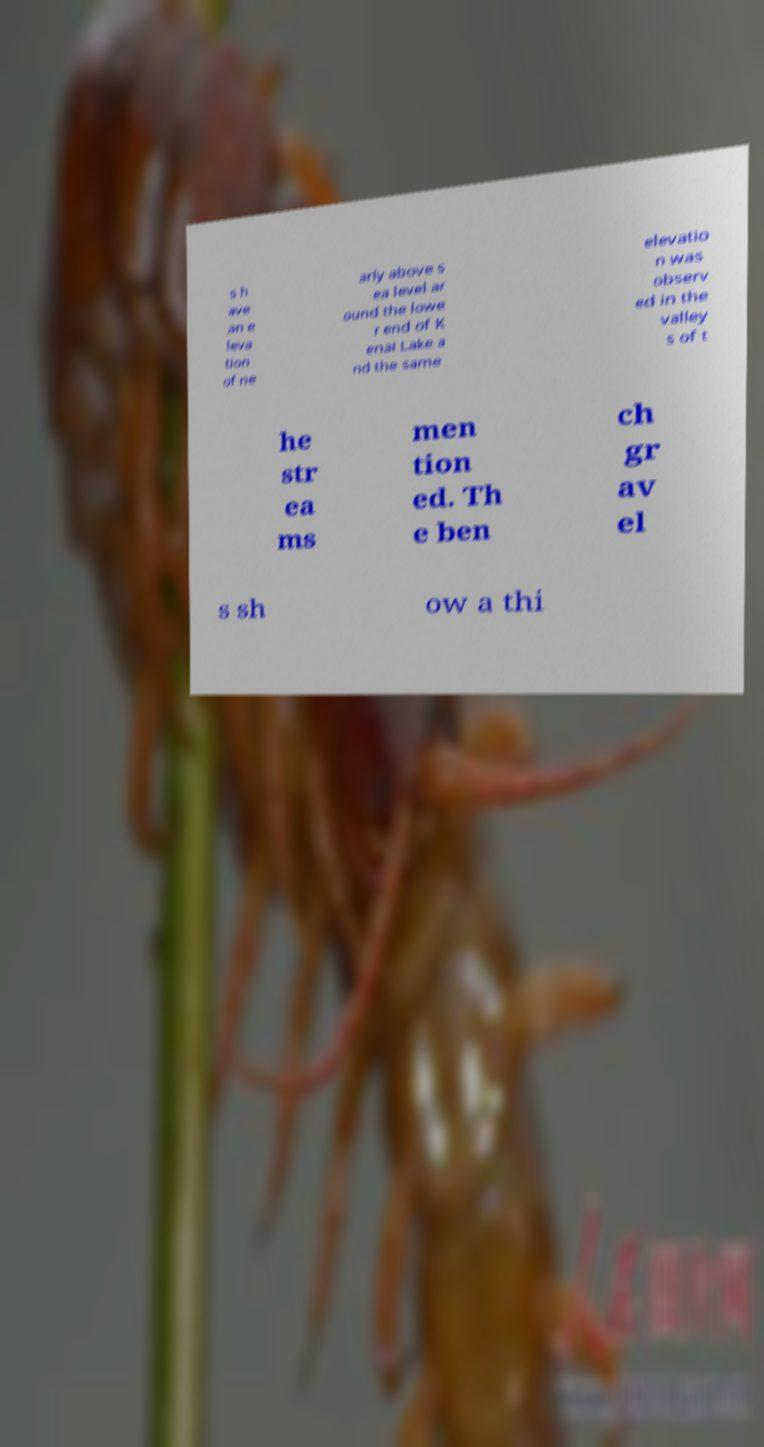Could you assist in decoding the text presented in this image and type it out clearly? s h ave an e leva tion of ne arly above s ea level ar ound the lowe r end of K enai Lake a nd the same elevatio n was observ ed in the valley s of t he str ea ms men tion ed. Th e ben ch gr av el s sh ow a thi 